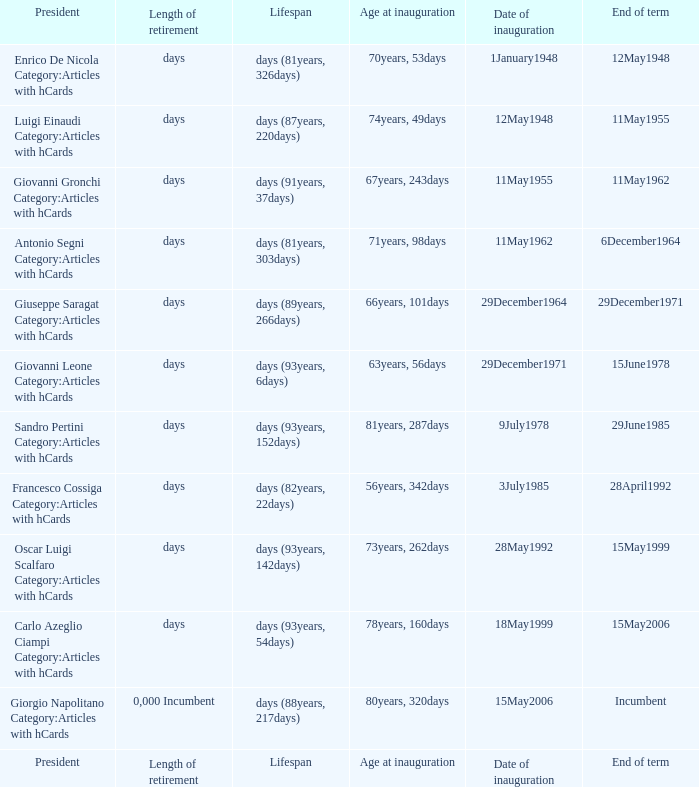Would you be able to parse every entry in this table? {'header': ['President', 'Length of retirement', 'Lifespan', 'Age at inauguration', 'Date of inauguration', 'End of term'], 'rows': [['Enrico De Nicola Category:Articles with hCards', 'days', 'days (81years, 326days)', '70years, 53days', '1January1948', '12May1948'], ['Luigi Einaudi Category:Articles with hCards', 'days', 'days (87years, 220days)', '74years, 49days', '12May1948', '11May1955'], ['Giovanni Gronchi Category:Articles with hCards', 'days', 'days (91years, 37days)', '67years, 243days', '11May1955', '11May1962'], ['Antonio Segni Category:Articles with hCards', 'days', 'days (81years, 303days)', '71years, 98days', '11May1962', '6December1964'], ['Giuseppe Saragat Category:Articles with hCards', 'days', 'days (89years, 266days)', '66years, 101days', '29December1964', '29December1971'], ['Giovanni Leone Category:Articles with hCards', 'days', 'days (93years, 6days)', '63years, 56days', '29December1971', '15June1978'], ['Sandro Pertini Category:Articles with hCards', 'days', 'days (93years, 152days)', '81years, 287days', '9July1978', '29June1985'], ['Francesco Cossiga Category:Articles with hCards', 'days', 'days (82years, 22days)', '56years, 342days', '3July1985', '28April1992'], ['Oscar Luigi Scalfaro Category:Articles with hCards', 'days', 'days (93years, 142days)', '73years, 262days', '28May1992', '15May1999'], ['Carlo Azeglio Ciampi Category:Articles with hCards', 'days', 'days (93years, 54days)', '78years, 160days', '18May1999', '15May2006'], ['Giorgio Napolitano Category:Articles with hCards', '0,000 Incumbent', 'days (88years, 217days)', '80years, 320days', '15May2006', 'Incumbent'], ['President', 'Length of retirement', 'Lifespan', 'Age at inauguration', 'Date of inauguration', 'End of term']]} What is the Length of retirement of the President with an Age at inauguration of 70years, 53days? Days. 